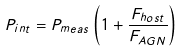Convert formula to latex. <formula><loc_0><loc_0><loc_500><loc_500>P _ { i n t } = P _ { m e a s } \left ( 1 + \frac { F _ { h o s t } } { F _ { A G N } } \right )</formula> 